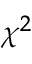Convert formula to latex. <formula><loc_0><loc_0><loc_500><loc_500>\chi ^ { 2 }</formula> 